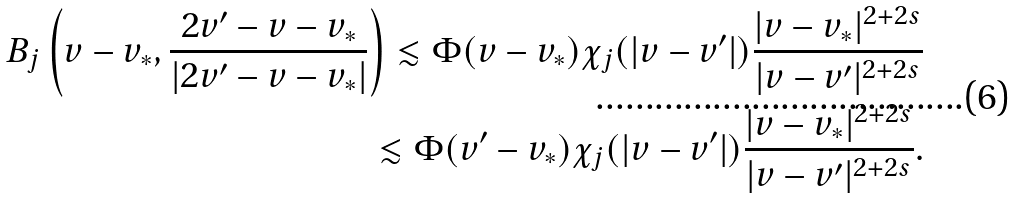<formula> <loc_0><loc_0><loc_500><loc_500>B _ { j } \left ( v - v _ { * } , \frac { 2 v ^ { \prime } - v - v _ { * } } { | 2 v ^ { \prime } - v - v _ { * } | } \right ) \lesssim \Phi ( v - v _ { * } ) \chi _ { j } ( | v - v ^ { \prime } | ) \frac { | v - v _ { * } | ^ { 2 + 2 s } } { | v - v ^ { \prime } | ^ { 2 + 2 s } } \\ \lesssim \Phi ( v ^ { \prime } - v _ { * } ) \chi _ { j } ( | v - v ^ { \prime } | ) \frac { | v - v _ { * } | ^ { 2 + 2 s } } { | v - v ^ { \prime } | ^ { 2 + 2 s } } .</formula> 